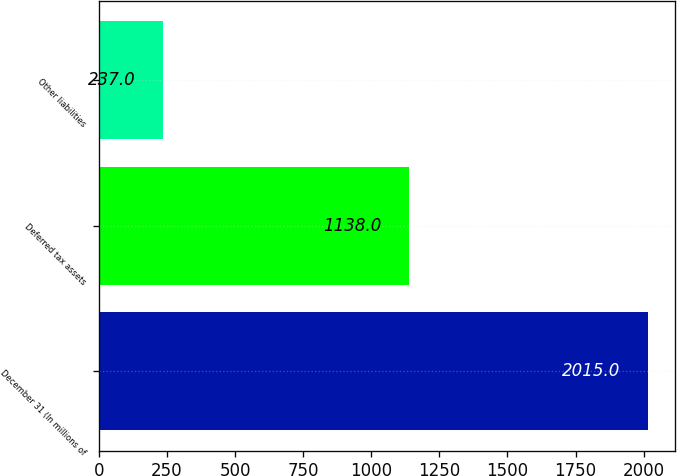<chart> <loc_0><loc_0><loc_500><loc_500><bar_chart><fcel>December 31 (In millions of<fcel>Deferred tax assets<fcel>Other liabilities<nl><fcel>2015<fcel>1138<fcel>237<nl></chart> 